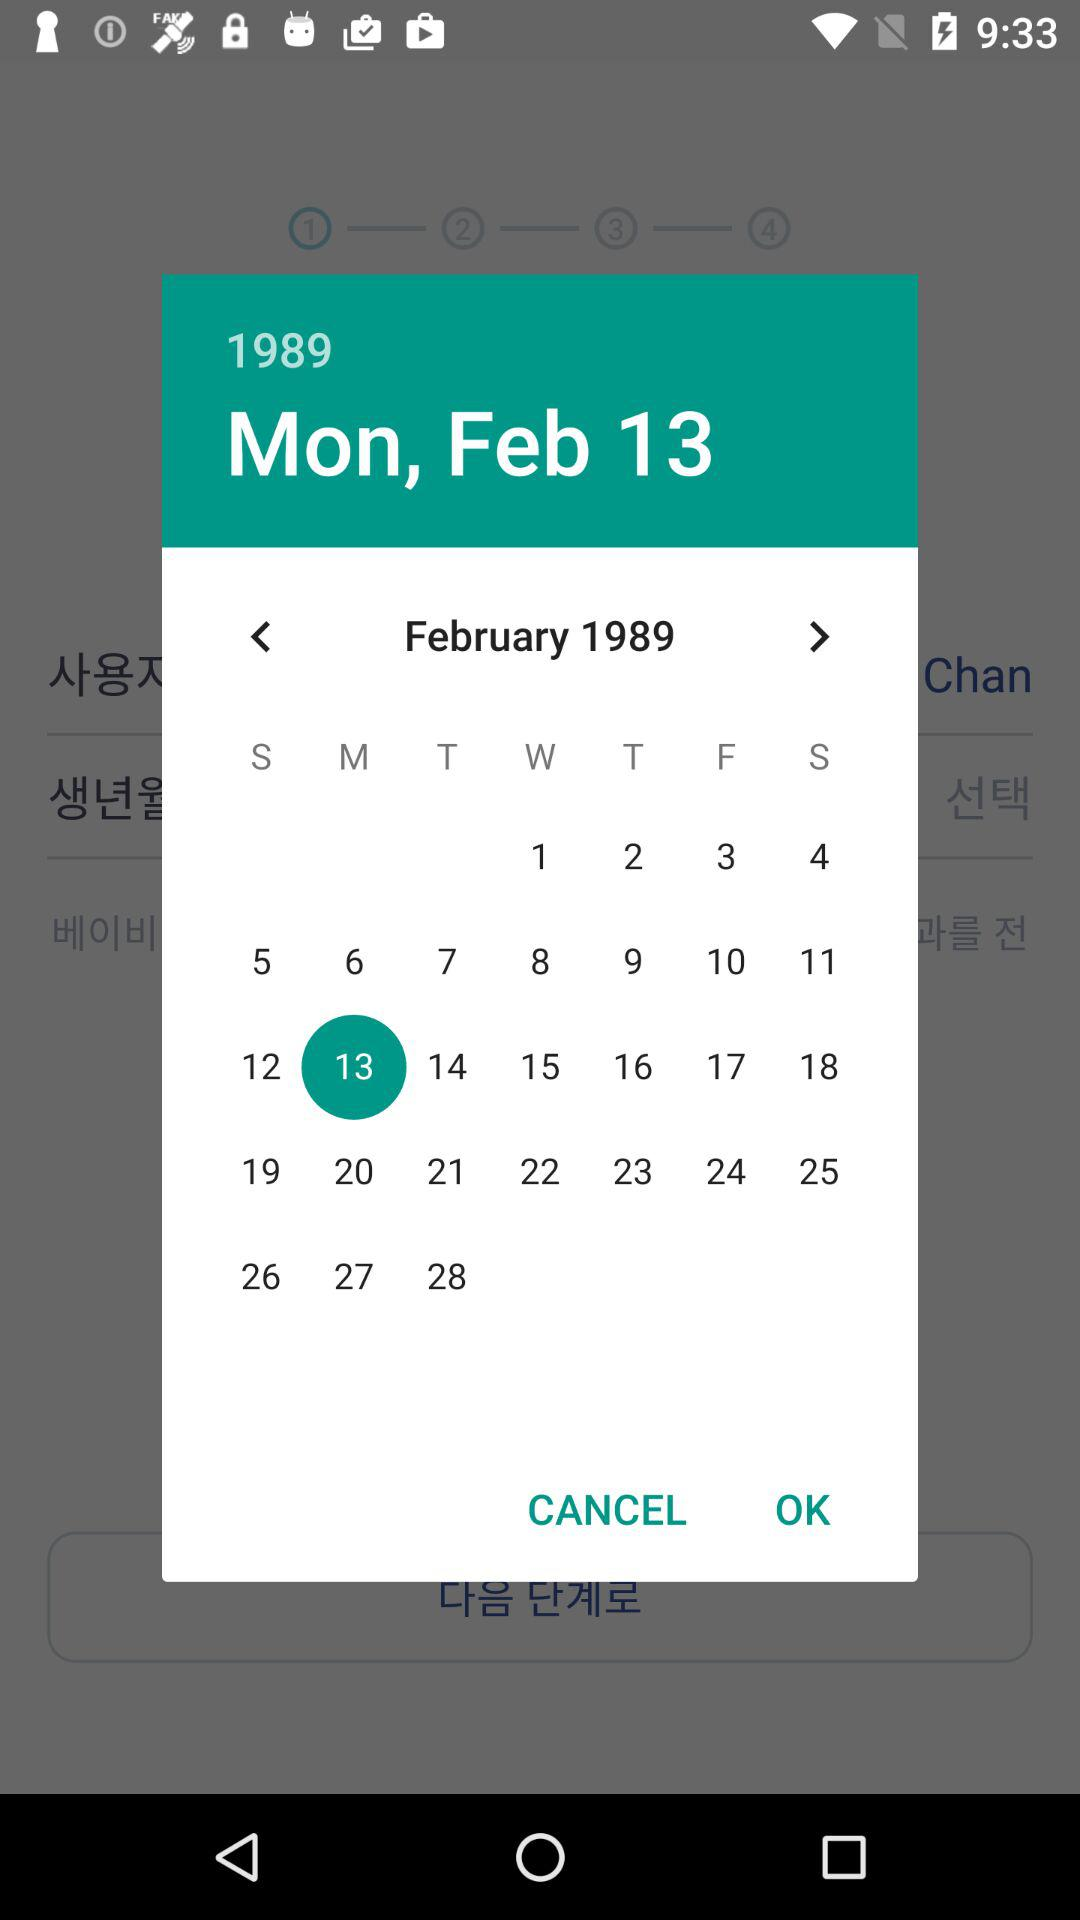What is the selected date? The selected date is Monday, February 13, 1989. 